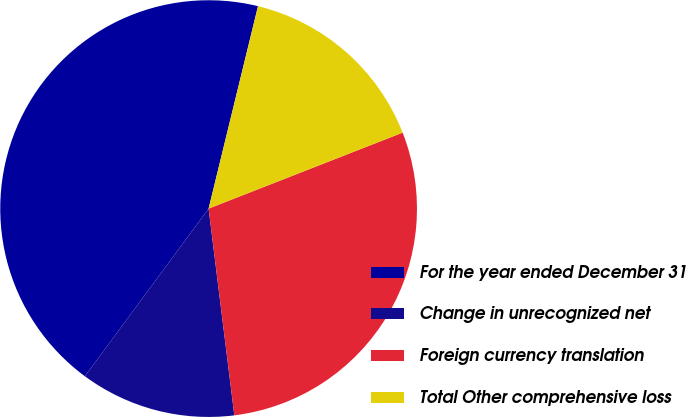Convert chart. <chart><loc_0><loc_0><loc_500><loc_500><pie_chart><fcel>For the year ended December 31<fcel>Change in unrecognized net<fcel>Foreign currency translation<fcel>Total Other comprehensive loss<nl><fcel>43.69%<fcel>12.09%<fcel>28.97%<fcel>15.25%<nl></chart> 